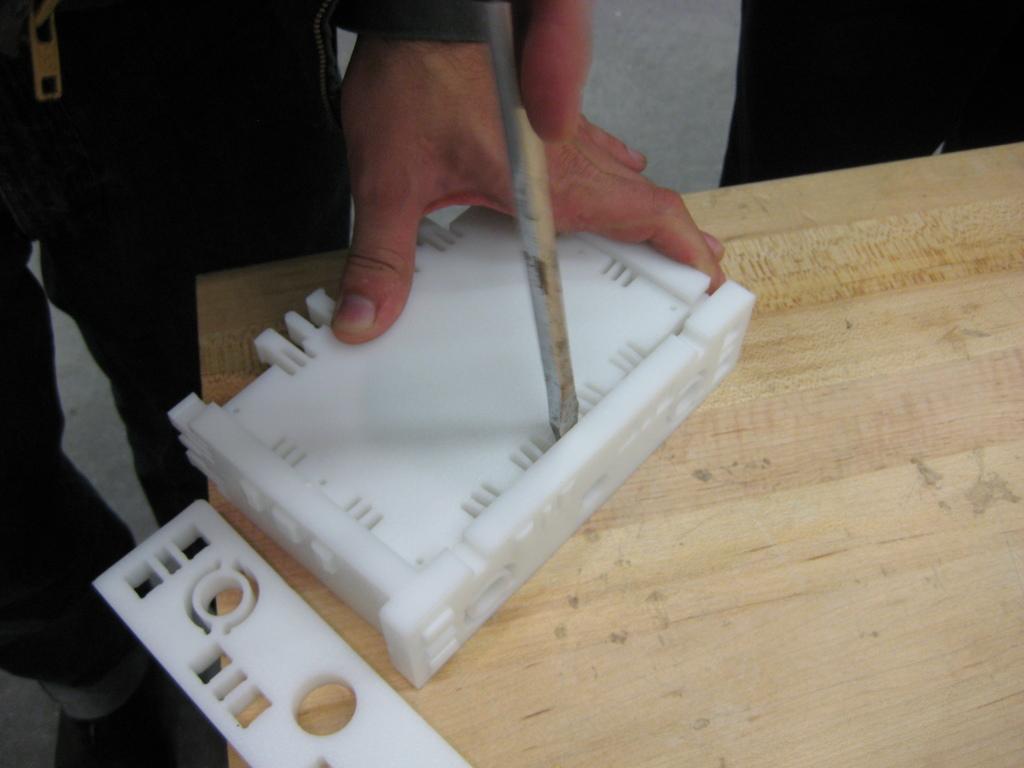In one or two sentences, can you explain what this image depicts? On the left side, there is a person holding a turn-screw and placing it on a white color object and holding this object with the other hand. This white color object is on a wooden table. Beside this object, there is another white color object. 